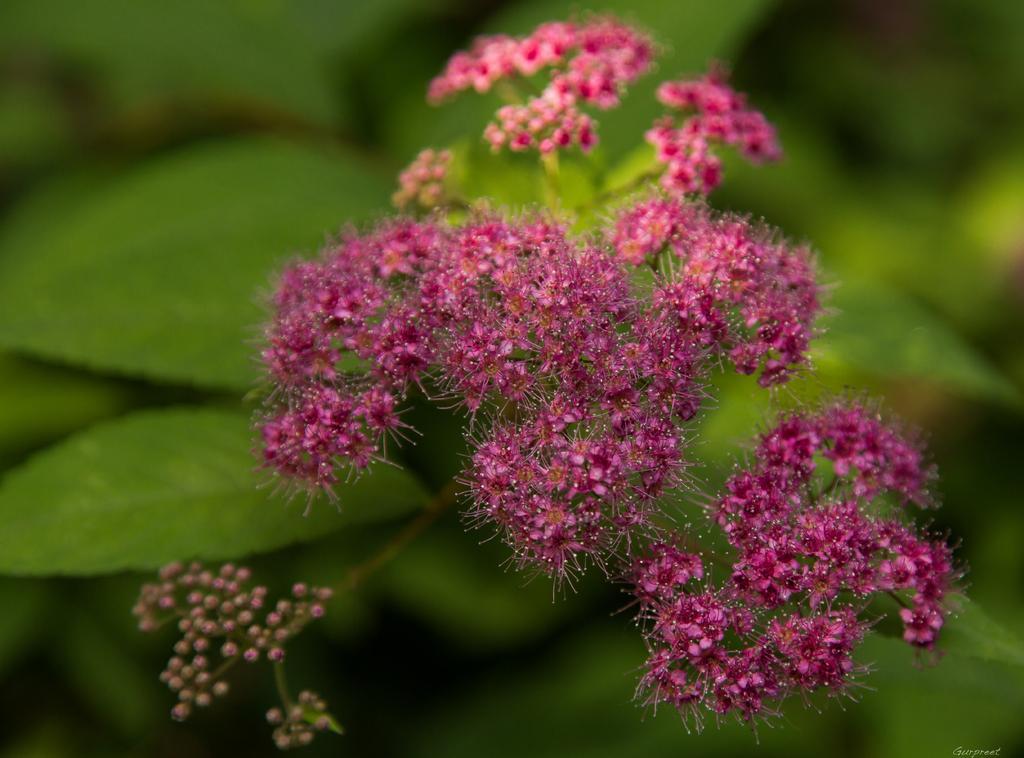Could you give a brief overview of what you see in this image? In this image I see the pink color flowers and I see the buds over here. In the background I see the green leaves and I see that it is blurred in the background. 